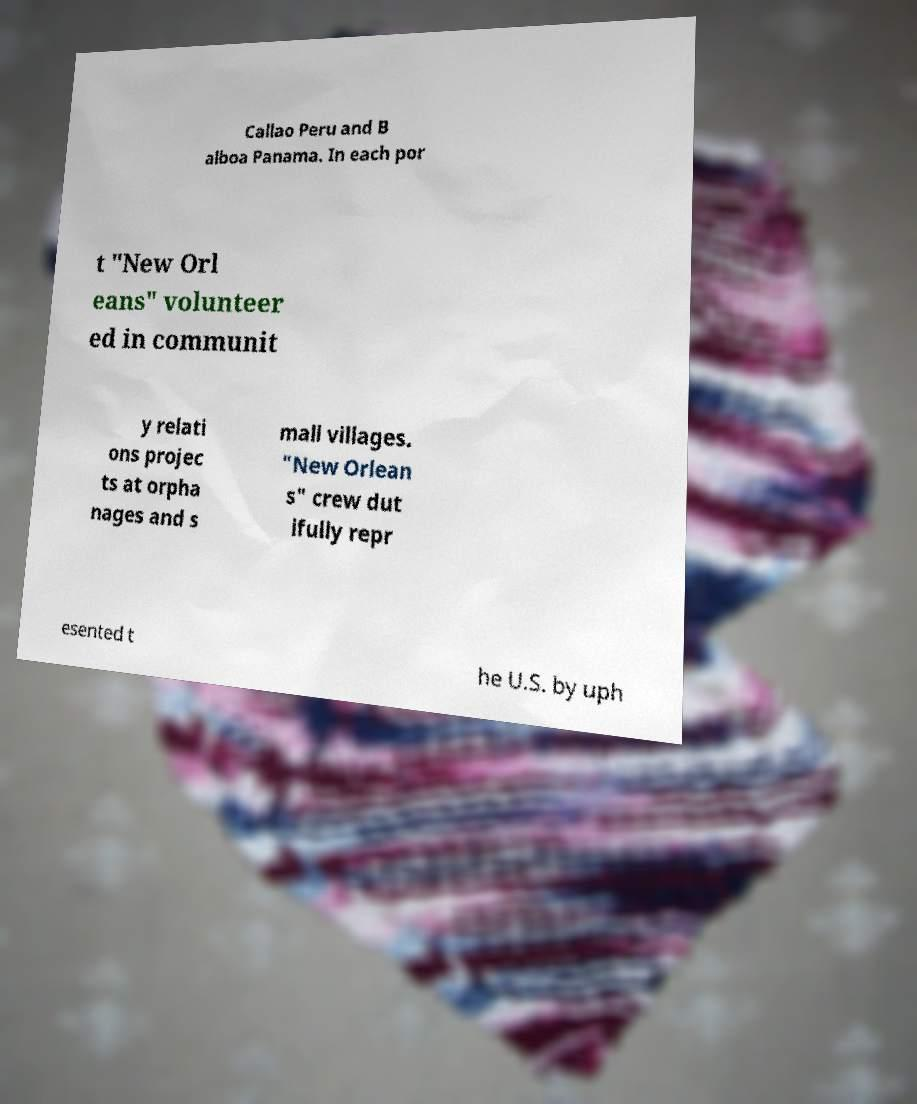I need the written content from this picture converted into text. Can you do that? Callao Peru and B alboa Panama. In each por t "New Orl eans" volunteer ed in communit y relati ons projec ts at orpha nages and s mall villages. "New Orlean s" crew dut ifully repr esented t he U.S. by uph 